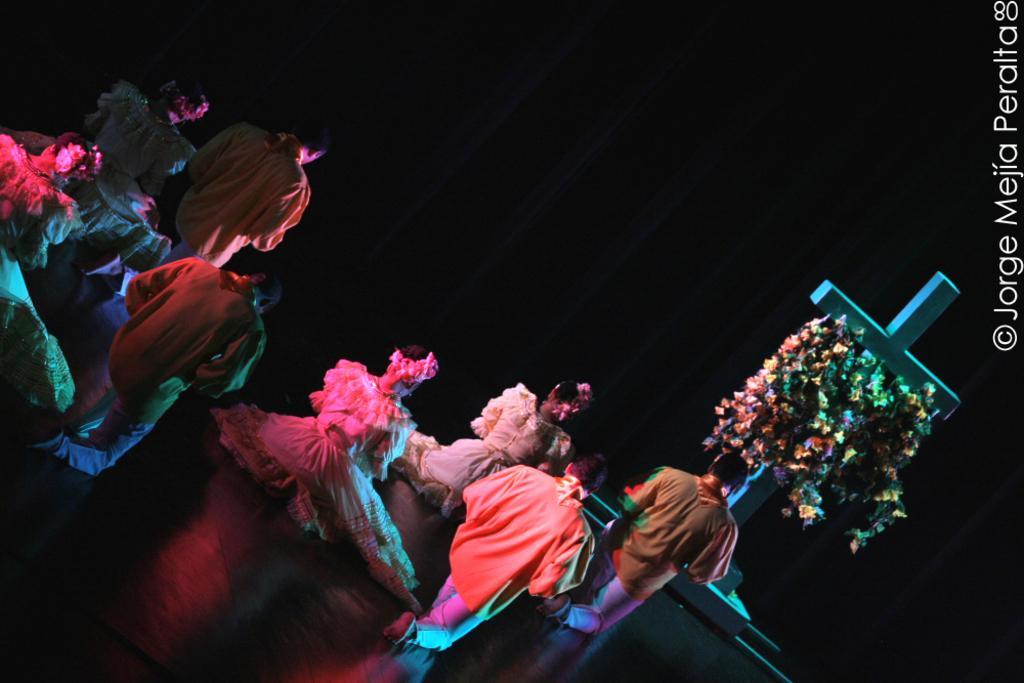In one or two sentences, can you explain what this image depicts? In the center of the image we can see a few people are performing and they are in different costumes. In front of them, there is a fence and stone. On the stone, there is a cross. On the cross, we can see a flower garland. 